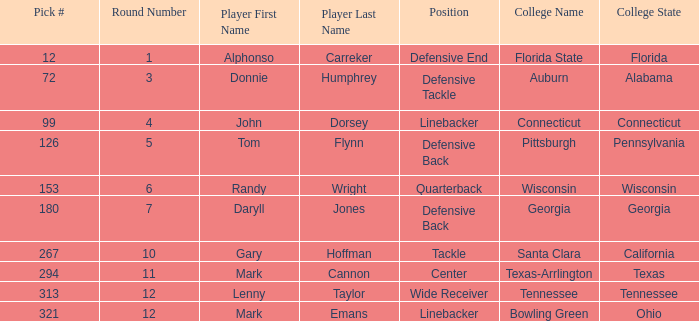During which round was the selection of the 12th pick made? Round 1. 